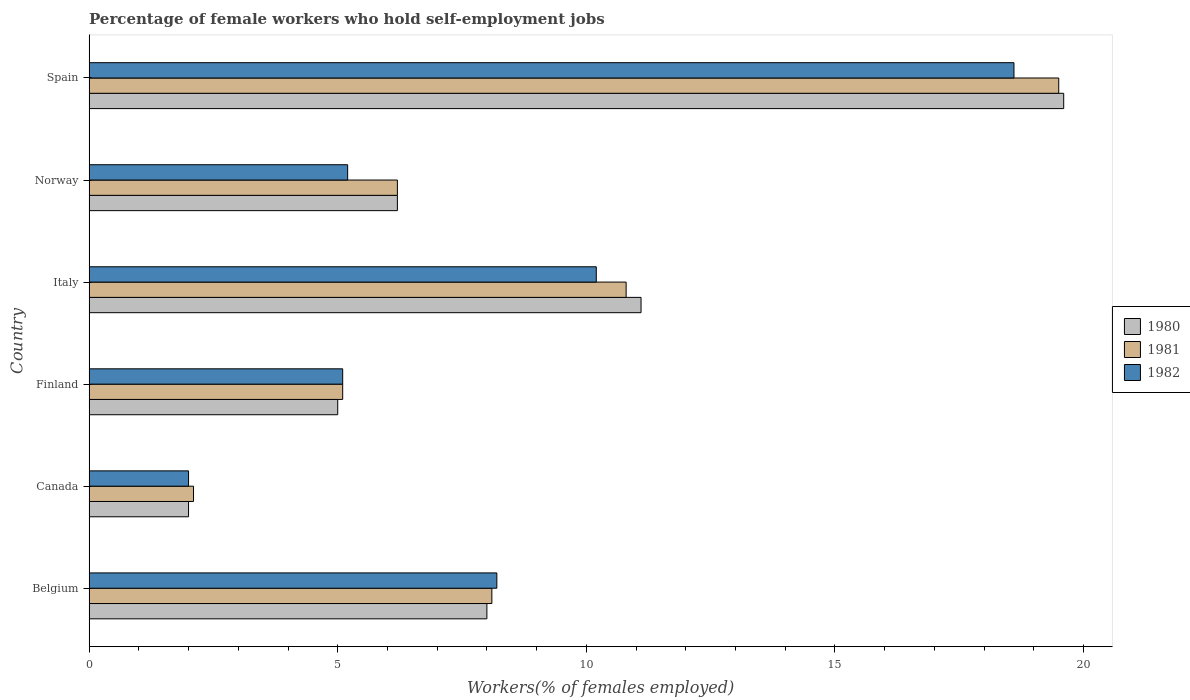Are the number of bars on each tick of the Y-axis equal?
Offer a terse response. Yes. How many bars are there on the 4th tick from the top?
Make the answer very short. 3. What is the label of the 3rd group of bars from the top?
Your answer should be very brief. Italy. What is the percentage of self-employed female workers in 1980 in Italy?
Your answer should be compact. 11.1. Across all countries, what is the maximum percentage of self-employed female workers in 1980?
Keep it short and to the point. 19.6. Across all countries, what is the minimum percentage of self-employed female workers in 1981?
Offer a terse response. 2.1. In which country was the percentage of self-employed female workers in 1980 maximum?
Your response must be concise. Spain. In which country was the percentage of self-employed female workers in 1980 minimum?
Your answer should be compact. Canada. What is the total percentage of self-employed female workers in 1980 in the graph?
Your answer should be very brief. 51.9. What is the difference between the percentage of self-employed female workers in 1980 in Belgium and that in Norway?
Ensure brevity in your answer.  1.8. What is the difference between the percentage of self-employed female workers in 1982 in Spain and the percentage of self-employed female workers in 1980 in Finland?
Give a very brief answer. 13.6. What is the average percentage of self-employed female workers in 1980 per country?
Your response must be concise. 8.65. What is the ratio of the percentage of self-employed female workers in 1981 in Canada to that in Italy?
Your answer should be compact. 0.19. What is the difference between the highest and the second highest percentage of self-employed female workers in 1980?
Offer a very short reply. 8.5. What is the difference between the highest and the lowest percentage of self-employed female workers in 1981?
Give a very brief answer. 17.4. In how many countries, is the percentage of self-employed female workers in 1981 greater than the average percentage of self-employed female workers in 1981 taken over all countries?
Provide a short and direct response. 2. Is the sum of the percentage of self-employed female workers in 1980 in Finland and Norway greater than the maximum percentage of self-employed female workers in 1982 across all countries?
Keep it short and to the point. No. What does the 1st bar from the top in Norway represents?
Your response must be concise. 1982. What does the 2nd bar from the bottom in Norway represents?
Your response must be concise. 1981. Is it the case that in every country, the sum of the percentage of self-employed female workers in 1981 and percentage of self-employed female workers in 1980 is greater than the percentage of self-employed female workers in 1982?
Give a very brief answer. Yes. Are all the bars in the graph horizontal?
Provide a short and direct response. Yes. What is the difference between two consecutive major ticks on the X-axis?
Give a very brief answer. 5. How many legend labels are there?
Ensure brevity in your answer.  3. How are the legend labels stacked?
Keep it short and to the point. Vertical. What is the title of the graph?
Your response must be concise. Percentage of female workers who hold self-employment jobs. What is the label or title of the X-axis?
Ensure brevity in your answer.  Workers(% of females employed). What is the label or title of the Y-axis?
Offer a terse response. Country. What is the Workers(% of females employed) in 1980 in Belgium?
Make the answer very short. 8. What is the Workers(% of females employed) of 1981 in Belgium?
Your answer should be very brief. 8.1. What is the Workers(% of females employed) of 1982 in Belgium?
Your answer should be compact. 8.2. What is the Workers(% of females employed) of 1980 in Canada?
Offer a very short reply. 2. What is the Workers(% of females employed) of 1981 in Canada?
Provide a short and direct response. 2.1. What is the Workers(% of females employed) of 1980 in Finland?
Offer a terse response. 5. What is the Workers(% of females employed) in 1981 in Finland?
Provide a succinct answer. 5.1. What is the Workers(% of females employed) of 1982 in Finland?
Offer a very short reply. 5.1. What is the Workers(% of females employed) in 1980 in Italy?
Offer a very short reply. 11.1. What is the Workers(% of females employed) of 1981 in Italy?
Offer a terse response. 10.8. What is the Workers(% of females employed) in 1982 in Italy?
Make the answer very short. 10.2. What is the Workers(% of females employed) in 1980 in Norway?
Your answer should be very brief. 6.2. What is the Workers(% of females employed) in 1981 in Norway?
Provide a short and direct response. 6.2. What is the Workers(% of females employed) of 1982 in Norway?
Your response must be concise. 5.2. What is the Workers(% of females employed) in 1980 in Spain?
Provide a succinct answer. 19.6. What is the Workers(% of females employed) of 1982 in Spain?
Keep it short and to the point. 18.6. Across all countries, what is the maximum Workers(% of females employed) in 1980?
Your response must be concise. 19.6. Across all countries, what is the maximum Workers(% of females employed) of 1981?
Provide a succinct answer. 19.5. Across all countries, what is the maximum Workers(% of females employed) in 1982?
Provide a succinct answer. 18.6. Across all countries, what is the minimum Workers(% of females employed) in 1980?
Your response must be concise. 2. Across all countries, what is the minimum Workers(% of females employed) of 1981?
Offer a terse response. 2.1. What is the total Workers(% of females employed) of 1980 in the graph?
Your answer should be very brief. 51.9. What is the total Workers(% of females employed) in 1981 in the graph?
Keep it short and to the point. 51.8. What is the total Workers(% of females employed) in 1982 in the graph?
Your answer should be very brief. 49.3. What is the difference between the Workers(% of females employed) in 1980 in Belgium and that in Canada?
Keep it short and to the point. 6. What is the difference between the Workers(% of females employed) in 1980 in Belgium and that in Finland?
Provide a succinct answer. 3. What is the difference between the Workers(% of females employed) of 1981 in Belgium and that in Finland?
Make the answer very short. 3. What is the difference between the Workers(% of females employed) of 1982 in Belgium and that in Finland?
Give a very brief answer. 3.1. What is the difference between the Workers(% of females employed) in 1980 in Belgium and that in Italy?
Make the answer very short. -3.1. What is the difference between the Workers(% of females employed) in 1981 in Belgium and that in Italy?
Give a very brief answer. -2.7. What is the difference between the Workers(% of females employed) of 1982 in Belgium and that in Italy?
Offer a terse response. -2. What is the difference between the Workers(% of females employed) in 1980 in Belgium and that in Norway?
Make the answer very short. 1.8. What is the difference between the Workers(% of females employed) of 1981 in Belgium and that in Norway?
Offer a very short reply. 1.9. What is the difference between the Workers(% of females employed) in 1980 in Belgium and that in Spain?
Offer a very short reply. -11.6. What is the difference between the Workers(% of females employed) in 1980 in Canada and that in Finland?
Ensure brevity in your answer.  -3. What is the difference between the Workers(% of females employed) of 1980 in Canada and that in Italy?
Your answer should be compact. -9.1. What is the difference between the Workers(% of females employed) of 1980 in Canada and that in Norway?
Provide a short and direct response. -4.2. What is the difference between the Workers(% of females employed) in 1980 in Canada and that in Spain?
Offer a terse response. -17.6. What is the difference between the Workers(% of females employed) of 1981 in Canada and that in Spain?
Provide a succinct answer. -17.4. What is the difference between the Workers(% of females employed) of 1982 in Canada and that in Spain?
Your response must be concise. -16.6. What is the difference between the Workers(% of females employed) in 1982 in Finland and that in Norway?
Your response must be concise. -0.1. What is the difference between the Workers(% of females employed) of 1980 in Finland and that in Spain?
Offer a very short reply. -14.6. What is the difference between the Workers(% of females employed) in 1981 in Finland and that in Spain?
Ensure brevity in your answer.  -14.4. What is the difference between the Workers(% of females employed) in 1982 in Italy and that in Spain?
Ensure brevity in your answer.  -8.4. What is the difference between the Workers(% of females employed) in 1980 in Norway and that in Spain?
Your answer should be compact. -13.4. What is the difference between the Workers(% of females employed) in 1981 in Norway and that in Spain?
Offer a very short reply. -13.3. What is the difference between the Workers(% of females employed) of 1980 in Belgium and the Workers(% of females employed) of 1981 in Canada?
Offer a terse response. 5.9. What is the difference between the Workers(% of females employed) in 1980 in Belgium and the Workers(% of females employed) in 1981 in Finland?
Ensure brevity in your answer.  2.9. What is the difference between the Workers(% of females employed) in 1980 in Belgium and the Workers(% of females employed) in 1982 in Finland?
Your answer should be compact. 2.9. What is the difference between the Workers(% of females employed) in 1980 in Belgium and the Workers(% of females employed) in 1981 in Italy?
Provide a succinct answer. -2.8. What is the difference between the Workers(% of females employed) of 1981 in Belgium and the Workers(% of females employed) of 1982 in Italy?
Provide a short and direct response. -2.1. What is the difference between the Workers(% of females employed) in 1980 in Belgium and the Workers(% of females employed) in 1981 in Norway?
Provide a succinct answer. 1.8. What is the difference between the Workers(% of females employed) of 1980 in Belgium and the Workers(% of females employed) of 1982 in Norway?
Offer a terse response. 2.8. What is the difference between the Workers(% of females employed) of 1981 in Belgium and the Workers(% of females employed) of 1982 in Norway?
Ensure brevity in your answer.  2.9. What is the difference between the Workers(% of females employed) in 1980 in Belgium and the Workers(% of females employed) in 1981 in Spain?
Give a very brief answer. -11.5. What is the difference between the Workers(% of females employed) of 1981 in Canada and the Workers(% of females employed) of 1982 in Finland?
Make the answer very short. -3. What is the difference between the Workers(% of females employed) of 1980 in Canada and the Workers(% of females employed) of 1982 in Norway?
Your answer should be very brief. -3.2. What is the difference between the Workers(% of females employed) in 1981 in Canada and the Workers(% of females employed) in 1982 in Norway?
Your answer should be compact. -3.1. What is the difference between the Workers(% of females employed) in 1980 in Canada and the Workers(% of females employed) in 1981 in Spain?
Your answer should be very brief. -17.5. What is the difference between the Workers(% of females employed) in 1980 in Canada and the Workers(% of females employed) in 1982 in Spain?
Offer a very short reply. -16.6. What is the difference between the Workers(% of females employed) in 1981 in Canada and the Workers(% of females employed) in 1982 in Spain?
Keep it short and to the point. -16.5. What is the difference between the Workers(% of females employed) in 1980 in Finland and the Workers(% of females employed) in 1981 in Italy?
Provide a succinct answer. -5.8. What is the difference between the Workers(% of females employed) of 1980 in Finland and the Workers(% of females employed) of 1982 in Italy?
Keep it short and to the point. -5.2. What is the difference between the Workers(% of females employed) of 1981 in Finland and the Workers(% of females employed) of 1982 in Italy?
Offer a very short reply. -5.1. What is the difference between the Workers(% of females employed) of 1980 in Finland and the Workers(% of females employed) of 1982 in Norway?
Provide a succinct answer. -0.2. What is the difference between the Workers(% of females employed) of 1981 in Finland and the Workers(% of females employed) of 1982 in Norway?
Provide a succinct answer. -0.1. What is the difference between the Workers(% of females employed) of 1980 in Finland and the Workers(% of females employed) of 1981 in Spain?
Provide a short and direct response. -14.5. What is the difference between the Workers(% of females employed) in 1981 in Finland and the Workers(% of females employed) in 1982 in Spain?
Provide a succinct answer. -13.5. What is the difference between the Workers(% of females employed) of 1980 in Italy and the Workers(% of females employed) of 1982 in Norway?
Keep it short and to the point. 5.9. What is the difference between the Workers(% of females employed) of 1980 in Italy and the Workers(% of females employed) of 1981 in Spain?
Ensure brevity in your answer.  -8.4. What is the difference between the Workers(% of females employed) of 1981 in Norway and the Workers(% of females employed) of 1982 in Spain?
Your answer should be compact. -12.4. What is the average Workers(% of females employed) in 1980 per country?
Your answer should be compact. 8.65. What is the average Workers(% of females employed) in 1981 per country?
Your response must be concise. 8.63. What is the average Workers(% of females employed) in 1982 per country?
Give a very brief answer. 8.22. What is the difference between the Workers(% of females employed) of 1980 and Workers(% of females employed) of 1982 in Belgium?
Offer a very short reply. -0.2. What is the difference between the Workers(% of females employed) of 1981 and Workers(% of females employed) of 1982 in Belgium?
Your answer should be compact. -0.1. What is the difference between the Workers(% of females employed) in 1980 and Workers(% of females employed) in 1981 in Finland?
Your answer should be very brief. -0.1. What is the difference between the Workers(% of females employed) in 1980 and Workers(% of females employed) in 1982 in Finland?
Ensure brevity in your answer.  -0.1. What is the difference between the Workers(% of females employed) in 1980 and Workers(% of females employed) in 1982 in Italy?
Make the answer very short. 0.9. What is the difference between the Workers(% of females employed) of 1980 and Workers(% of females employed) of 1981 in Spain?
Your answer should be very brief. 0.1. What is the difference between the Workers(% of females employed) in 1981 and Workers(% of females employed) in 1982 in Spain?
Provide a short and direct response. 0.9. What is the ratio of the Workers(% of females employed) of 1980 in Belgium to that in Canada?
Ensure brevity in your answer.  4. What is the ratio of the Workers(% of females employed) of 1981 in Belgium to that in Canada?
Provide a short and direct response. 3.86. What is the ratio of the Workers(% of females employed) in 1982 in Belgium to that in Canada?
Provide a short and direct response. 4.1. What is the ratio of the Workers(% of females employed) of 1981 in Belgium to that in Finland?
Give a very brief answer. 1.59. What is the ratio of the Workers(% of females employed) of 1982 in Belgium to that in Finland?
Ensure brevity in your answer.  1.61. What is the ratio of the Workers(% of females employed) of 1980 in Belgium to that in Italy?
Offer a terse response. 0.72. What is the ratio of the Workers(% of females employed) in 1981 in Belgium to that in Italy?
Provide a short and direct response. 0.75. What is the ratio of the Workers(% of females employed) in 1982 in Belgium to that in Italy?
Give a very brief answer. 0.8. What is the ratio of the Workers(% of females employed) of 1980 in Belgium to that in Norway?
Make the answer very short. 1.29. What is the ratio of the Workers(% of females employed) of 1981 in Belgium to that in Norway?
Your response must be concise. 1.31. What is the ratio of the Workers(% of females employed) in 1982 in Belgium to that in Norway?
Your answer should be very brief. 1.58. What is the ratio of the Workers(% of females employed) of 1980 in Belgium to that in Spain?
Offer a terse response. 0.41. What is the ratio of the Workers(% of females employed) of 1981 in Belgium to that in Spain?
Keep it short and to the point. 0.42. What is the ratio of the Workers(% of females employed) of 1982 in Belgium to that in Spain?
Your response must be concise. 0.44. What is the ratio of the Workers(% of females employed) in 1981 in Canada to that in Finland?
Offer a terse response. 0.41. What is the ratio of the Workers(% of females employed) in 1982 in Canada to that in Finland?
Ensure brevity in your answer.  0.39. What is the ratio of the Workers(% of females employed) of 1980 in Canada to that in Italy?
Your answer should be very brief. 0.18. What is the ratio of the Workers(% of females employed) of 1981 in Canada to that in Italy?
Make the answer very short. 0.19. What is the ratio of the Workers(% of females employed) in 1982 in Canada to that in Italy?
Offer a terse response. 0.2. What is the ratio of the Workers(% of females employed) in 1980 in Canada to that in Norway?
Your answer should be compact. 0.32. What is the ratio of the Workers(% of females employed) in 1981 in Canada to that in Norway?
Your answer should be very brief. 0.34. What is the ratio of the Workers(% of females employed) in 1982 in Canada to that in Norway?
Offer a very short reply. 0.38. What is the ratio of the Workers(% of females employed) of 1980 in Canada to that in Spain?
Give a very brief answer. 0.1. What is the ratio of the Workers(% of females employed) of 1981 in Canada to that in Spain?
Provide a short and direct response. 0.11. What is the ratio of the Workers(% of females employed) of 1982 in Canada to that in Spain?
Keep it short and to the point. 0.11. What is the ratio of the Workers(% of females employed) of 1980 in Finland to that in Italy?
Your response must be concise. 0.45. What is the ratio of the Workers(% of females employed) of 1981 in Finland to that in Italy?
Provide a short and direct response. 0.47. What is the ratio of the Workers(% of females employed) of 1982 in Finland to that in Italy?
Your response must be concise. 0.5. What is the ratio of the Workers(% of females employed) of 1980 in Finland to that in Norway?
Offer a very short reply. 0.81. What is the ratio of the Workers(% of females employed) in 1981 in Finland to that in Norway?
Provide a short and direct response. 0.82. What is the ratio of the Workers(% of females employed) in 1982 in Finland to that in Norway?
Provide a short and direct response. 0.98. What is the ratio of the Workers(% of females employed) of 1980 in Finland to that in Spain?
Provide a short and direct response. 0.26. What is the ratio of the Workers(% of females employed) of 1981 in Finland to that in Spain?
Make the answer very short. 0.26. What is the ratio of the Workers(% of females employed) of 1982 in Finland to that in Spain?
Provide a short and direct response. 0.27. What is the ratio of the Workers(% of females employed) of 1980 in Italy to that in Norway?
Make the answer very short. 1.79. What is the ratio of the Workers(% of females employed) of 1981 in Italy to that in Norway?
Provide a succinct answer. 1.74. What is the ratio of the Workers(% of females employed) of 1982 in Italy to that in Norway?
Your answer should be compact. 1.96. What is the ratio of the Workers(% of females employed) of 1980 in Italy to that in Spain?
Provide a succinct answer. 0.57. What is the ratio of the Workers(% of females employed) of 1981 in Italy to that in Spain?
Your response must be concise. 0.55. What is the ratio of the Workers(% of females employed) in 1982 in Italy to that in Spain?
Your answer should be very brief. 0.55. What is the ratio of the Workers(% of females employed) in 1980 in Norway to that in Spain?
Give a very brief answer. 0.32. What is the ratio of the Workers(% of females employed) in 1981 in Norway to that in Spain?
Ensure brevity in your answer.  0.32. What is the ratio of the Workers(% of females employed) of 1982 in Norway to that in Spain?
Your answer should be compact. 0.28. What is the difference between the highest and the second highest Workers(% of females employed) of 1980?
Offer a terse response. 8.5. What is the difference between the highest and the lowest Workers(% of females employed) of 1980?
Give a very brief answer. 17.6. What is the difference between the highest and the lowest Workers(% of females employed) in 1981?
Offer a very short reply. 17.4. 